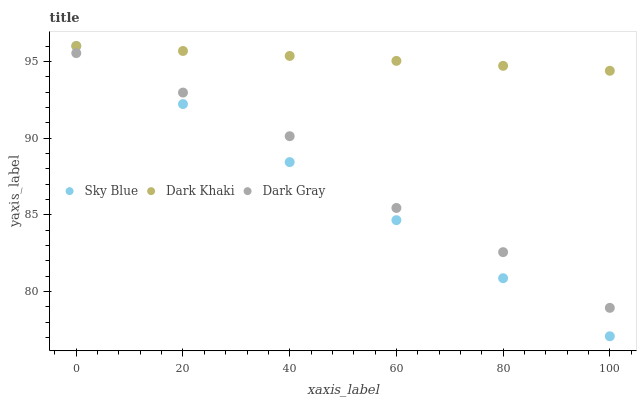Does Sky Blue have the minimum area under the curve?
Answer yes or no. Yes. Does Dark Khaki have the maximum area under the curve?
Answer yes or no. Yes. Does Dark Gray have the minimum area under the curve?
Answer yes or no. No. Does Dark Gray have the maximum area under the curve?
Answer yes or no. No. Is Sky Blue the smoothest?
Answer yes or no. Yes. Is Dark Gray the roughest?
Answer yes or no. Yes. Is Dark Gray the smoothest?
Answer yes or no. No. Is Sky Blue the roughest?
Answer yes or no. No. Does Sky Blue have the lowest value?
Answer yes or no. Yes. Does Dark Gray have the lowest value?
Answer yes or no. No. Does Sky Blue have the highest value?
Answer yes or no. Yes. Does Dark Gray have the highest value?
Answer yes or no. No. Is Dark Gray less than Dark Khaki?
Answer yes or no. Yes. Is Dark Khaki greater than Dark Gray?
Answer yes or no. Yes. Does Sky Blue intersect Dark Gray?
Answer yes or no. Yes. Is Sky Blue less than Dark Gray?
Answer yes or no. No. Is Sky Blue greater than Dark Gray?
Answer yes or no. No. Does Dark Gray intersect Dark Khaki?
Answer yes or no. No. 